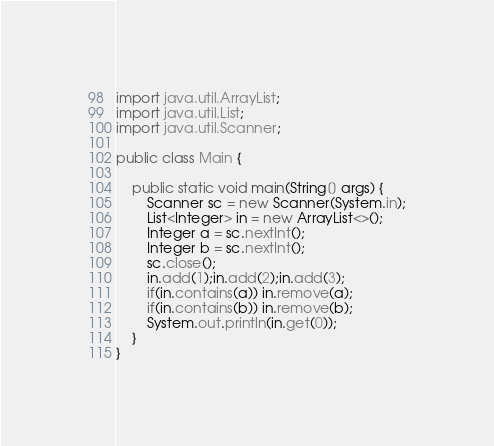Convert code to text. <code><loc_0><loc_0><loc_500><loc_500><_Java_>import java.util.ArrayList;
import java.util.List;
import java.util.Scanner;

public class Main {

	public static void main(String[] args) {
		Scanner sc = new Scanner(System.in);
		List<Integer> in = new ArrayList<>();
		Integer a = sc.nextInt();
		Integer b = sc.nextInt();
		sc.close();
		in.add(1);in.add(2);in.add(3);
		if(in.contains(a)) in.remove(a);
		if(in.contains(b)) in.remove(b);
		System.out.println(in.get(0));
	}
}
</code> 